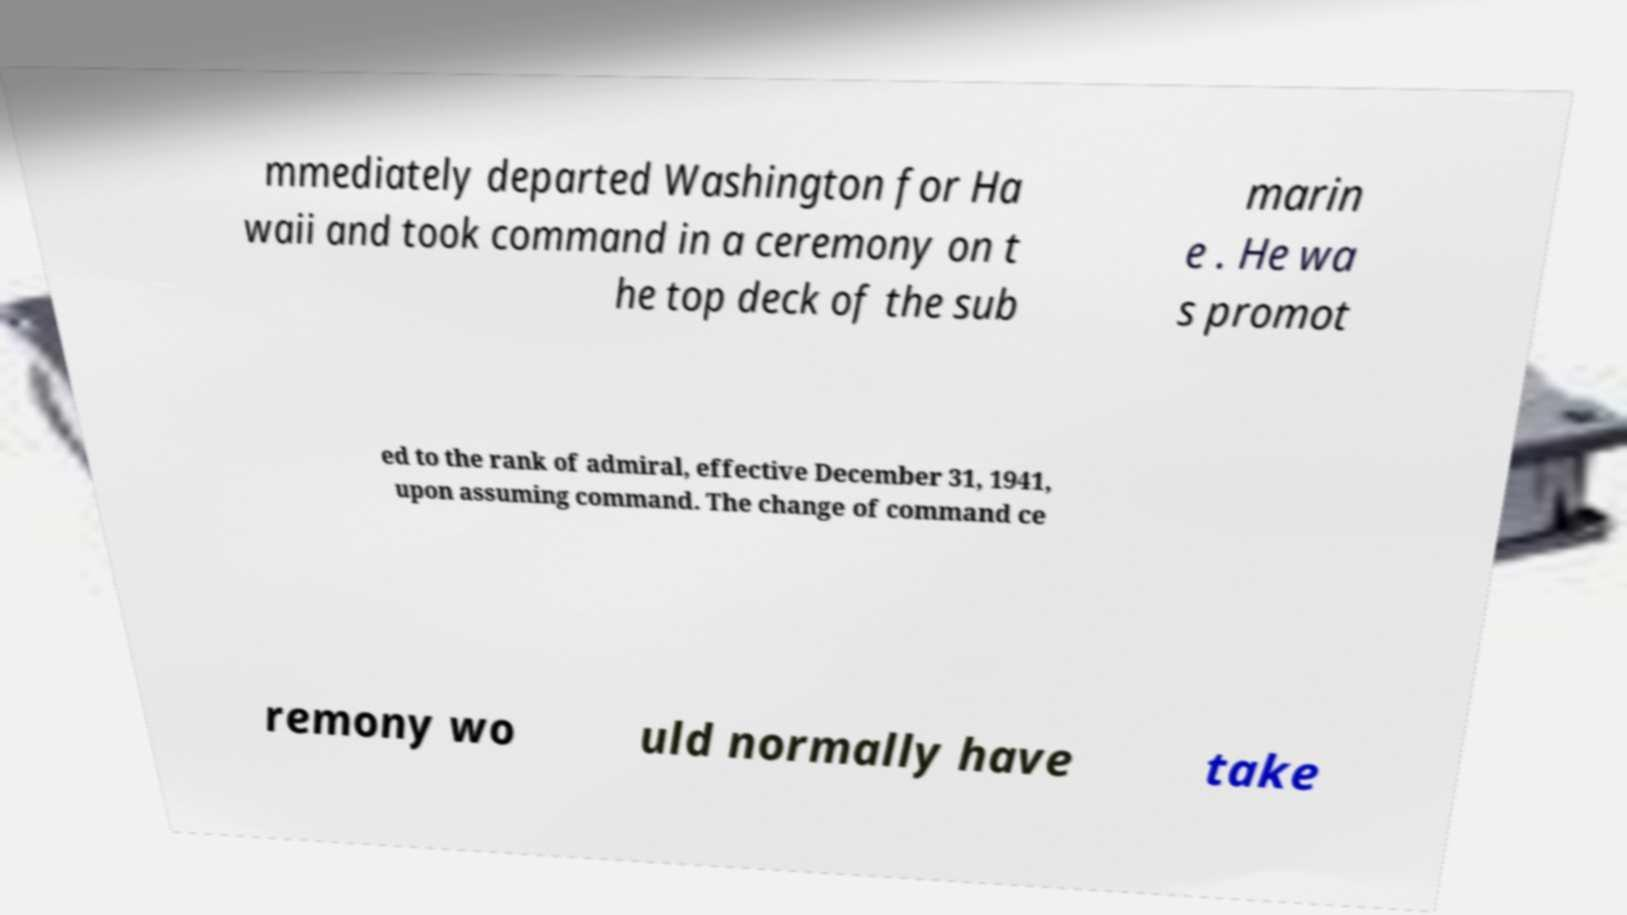Could you assist in decoding the text presented in this image and type it out clearly? mmediately departed Washington for Ha waii and took command in a ceremony on t he top deck of the sub marin e . He wa s promot ed to the rank of admiral, effective December 31, 1941, upon assuming command. The change of command ce remony wo uld normally have take 